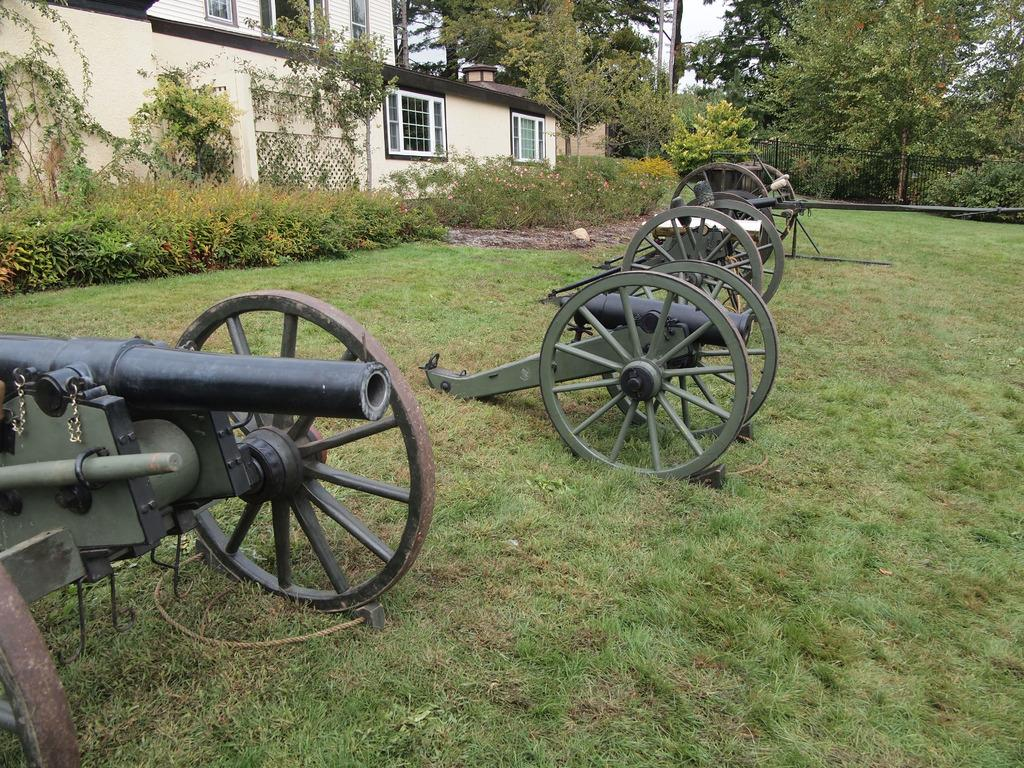What is located in the center of the image? There are vehicles in the center of the image. What type of vegetation is at the bottom of the image? There is grass at the bottom of the image. What can be seen in the background of the image? There is a fence, a house, trees, and plants in the background of the image. What is present in the center of the image besides the vehicles? There is a pole in the center of the image. What type of stone is used to create the musical instrument in the image? There is no musical instrument or stone present in the image. What ornament is hanging from the trees in the background of the image? There are no ornaments hanging from the trees in the background of the image. 